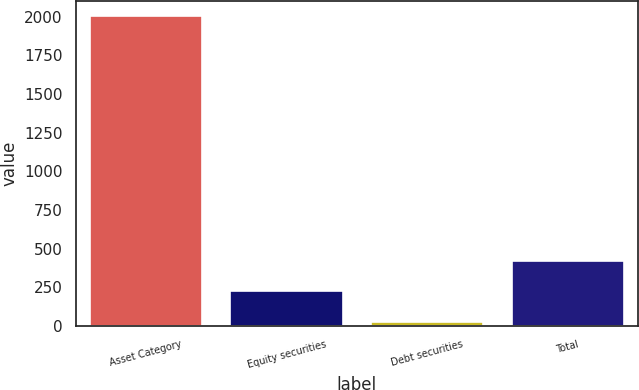<chart> <loc_0><loc_0><loc_500><loc_500><bar_chart><fcel>Asset Category<fcel>Equity securities<fcel>Debt securities<fcel>Total<nl><fcel>2004<fcel>224.7<fcel>27<fcel>422.4<nl></chart> 